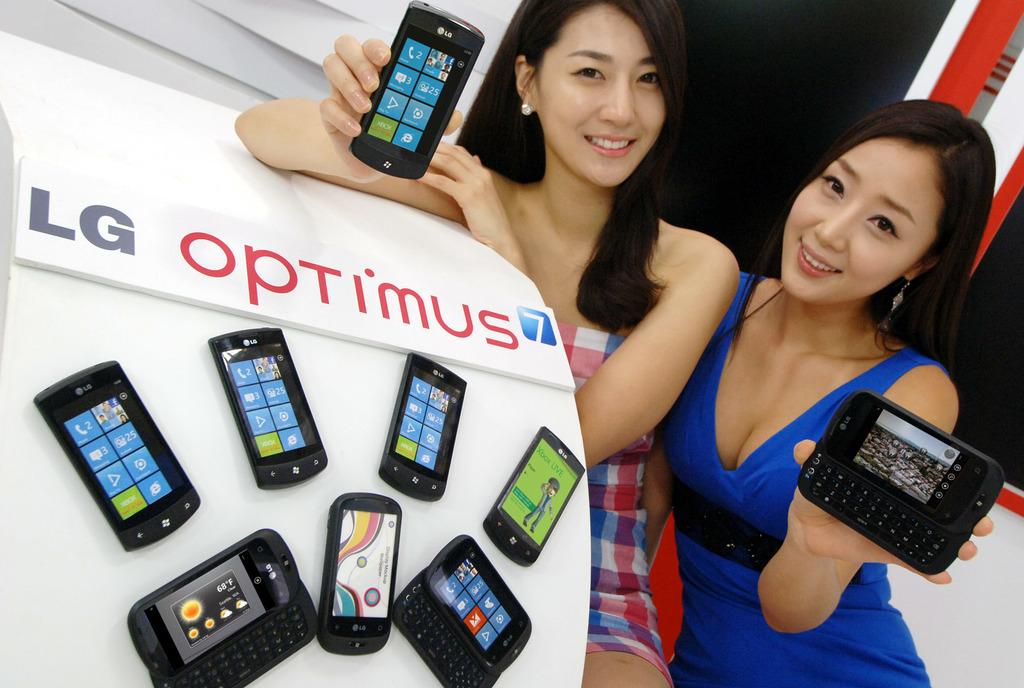How many women are in the image? There are two women in the image. What are the women holding in their hands? Both women are holding mobiles. What position are the women in? The women are sitting. What expression do the women have on their faces? The women are smiling. Are there any other mobiles visible in the image? Yes, there are mobiles on a platform beside the women. How many feet can be seen in the image? There is no information about feet in the image, as it only shows two women holding mobiles and sitting. 